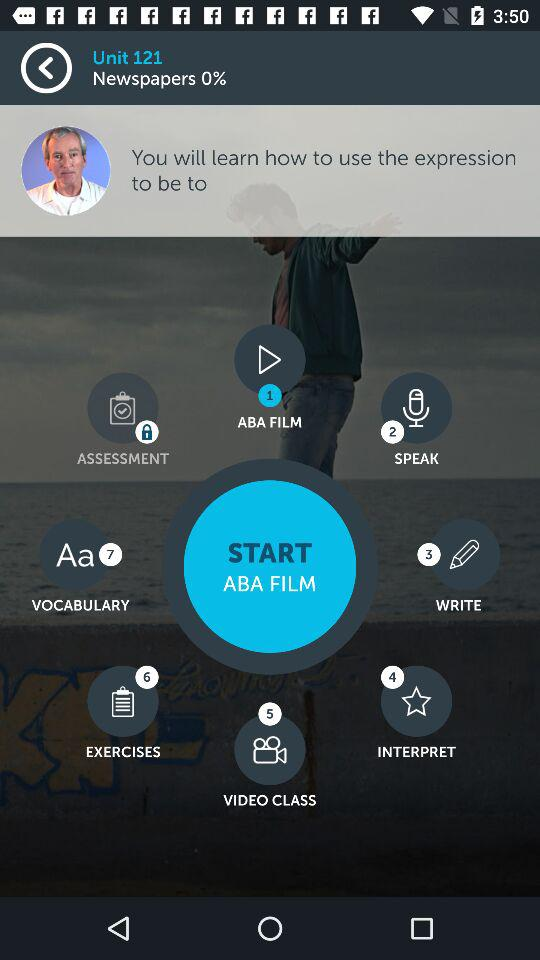What is the percentage for the "Newspapers"? The percentage for the "Newspapers" is 0. 